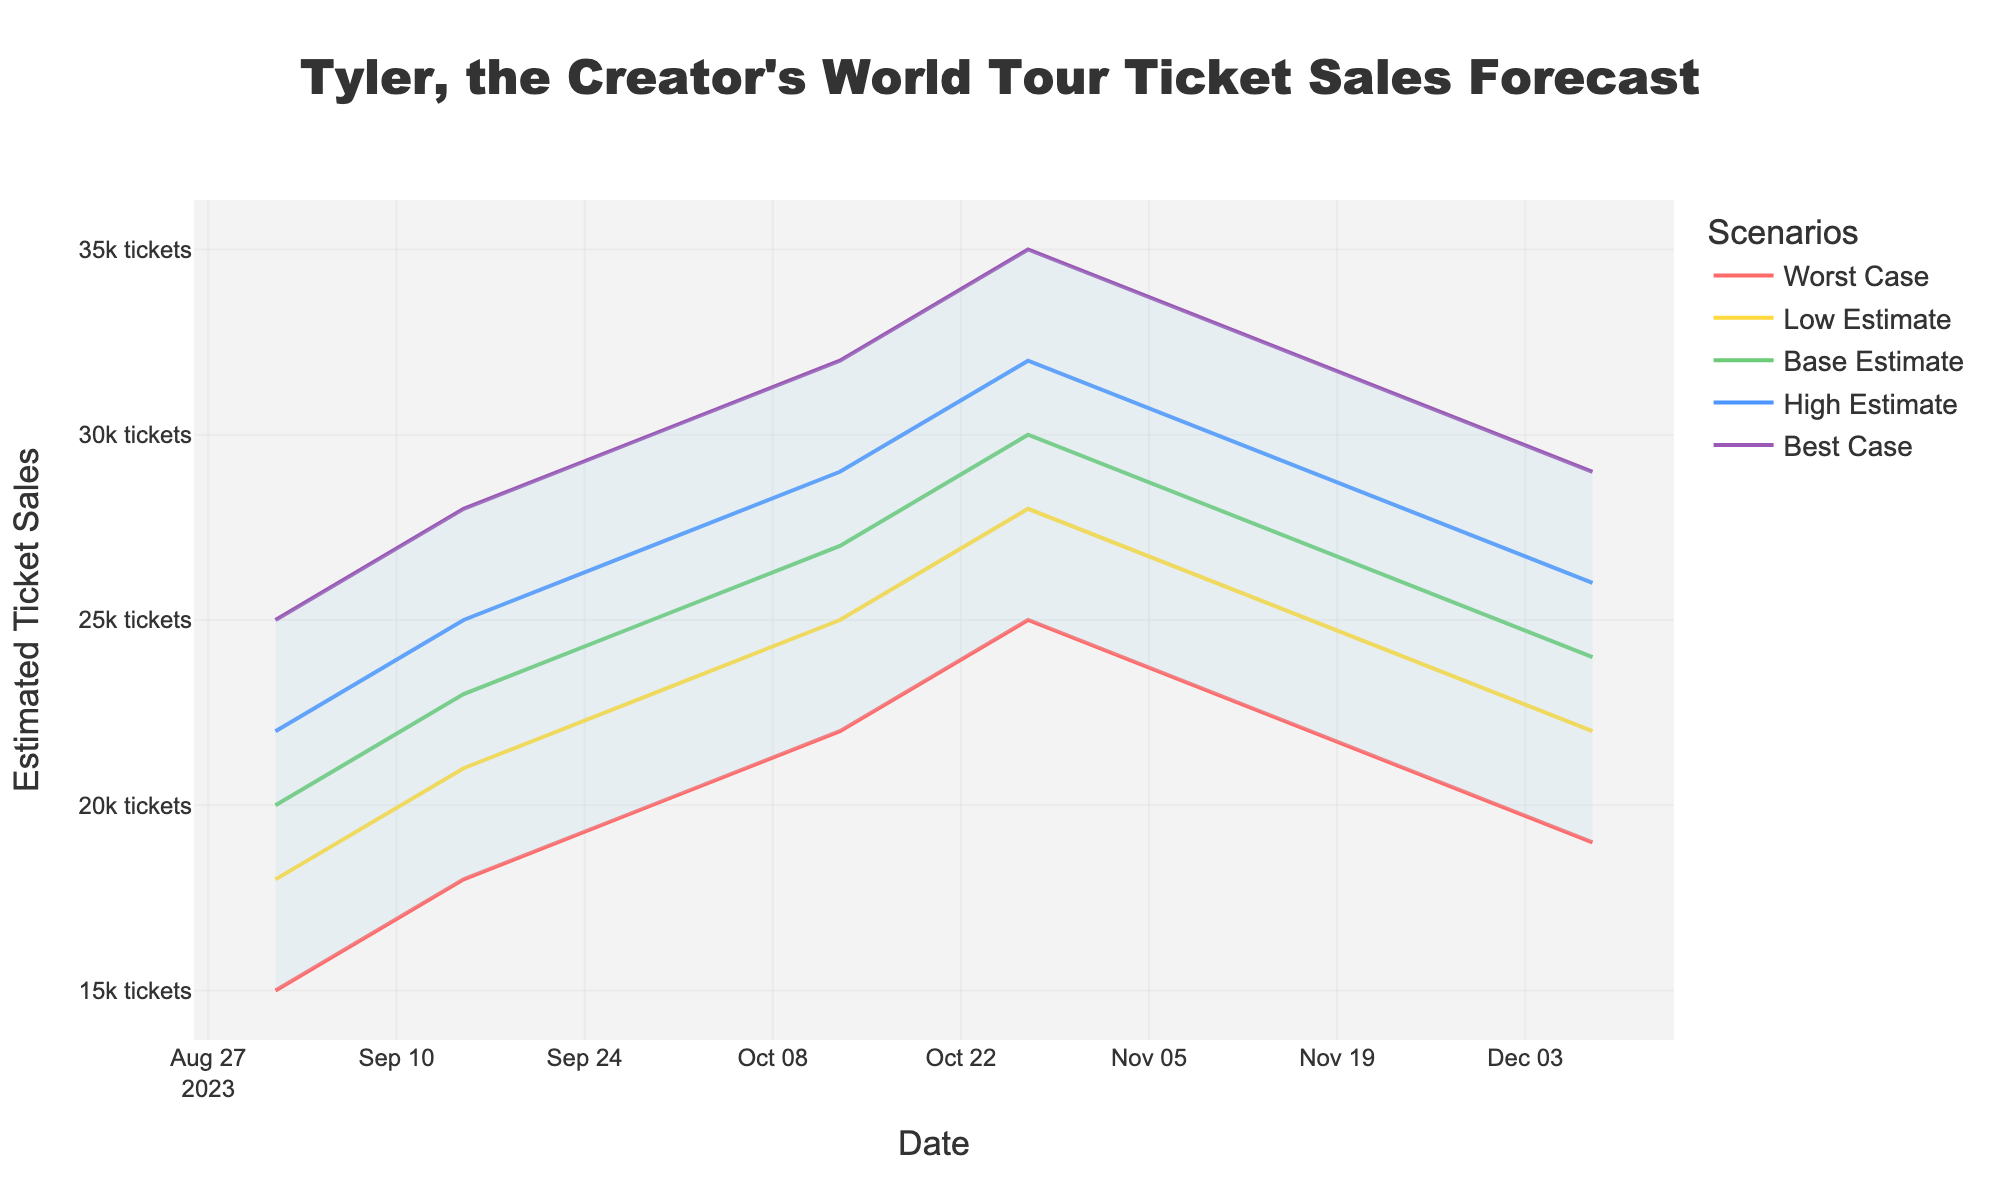What is the title of the figure? The title is usually displayed at the top of the figure. Here it is clearly stated as "Tyler, the Creator's World Tour Ticket Sales Forecast".
Answer: Tyler, the Creator's World Tour Ticket Sales Forecast How many scenarios are shown in the plot? By looking at the legend or the different lines shown in the figure, you can count the number of scenarios. The legend shows five scenarios: Worst Case, Low Estimate, Base Estimate, High Estimate, and Best Case.
Answer: Five What is the lowest sales estimate on December 8, 2023? Refer to the 'Worst Case' scenario line at the date closest to December 8, 2023. The value indicated is 19,000 tickets.
Answer: 19,000 On which date does the 'Best Case' scenario predict reaching 35,000 ticket sales? Track the 'Best Case' line to see when it intersects the 35,000 ticket mark. This occurs on October 27, 2023.
Answer: October 27, 2023 How do the sales estimates change from October 13 to November 10 in the 'Base Estimate' scenario? Compare the values of the 'Base Estimate' scenario on these two dates. On October 13, the estimate is 27,000 tickets, and on November 10, it is 28,000 tickets. The change is an increase of 1,000 tickets.
Answer: Increase by 1,000 tickets Which date has the smallest gap between the 'Best Case' and 'Worst Case' scenarios? Calculate the gap by subtracting the 'Worst Case' from the 'Best Case' for each date, then find the smallest gap. On December 8, 2023, the gap is 10,000 tickets (29,000 - 19,000), which is the smallest among all dates.
Answer: December 8, 2023 What is the average ticket sale estimate for September 2023 in the 'Base Estimate' scenario? To find the average, add the 'Base Estimate' values for dates in September and divide by the number of dates: (20,000 + 23,000 + 25,000)/3. This results in an average of 22,667 tickets.
Answer: 22,667 tickets By how much do the 'Low Estimate' values change from the start of the forecast to the end? Subtract the 'Low Estimate' value on the last date (22,000 tickets on December 8) from the first date (18,000 tickets on September 1): 22,000 - 18,000 = 4,000.
Answer: Increase by 4,000 tickets Which scenario shows a peak ticket sale estimate on October 27, 2023? Look at all scenario lines on October 27, 2023. The highest value is provided by the 'Best Case' scenario, which is 35,000 tickets.
Answer: Best Case When comparing the 'Base Estimate' and 'High Estimate' scenarios, on which date is their difference the greatest? Calculate the difference for each date and identify the maximum difference. On October 27, 2023, the difference is 20,000 - 27,000 = 5,000 tickets, which is the greatest.
Answer: October 27, 2023 